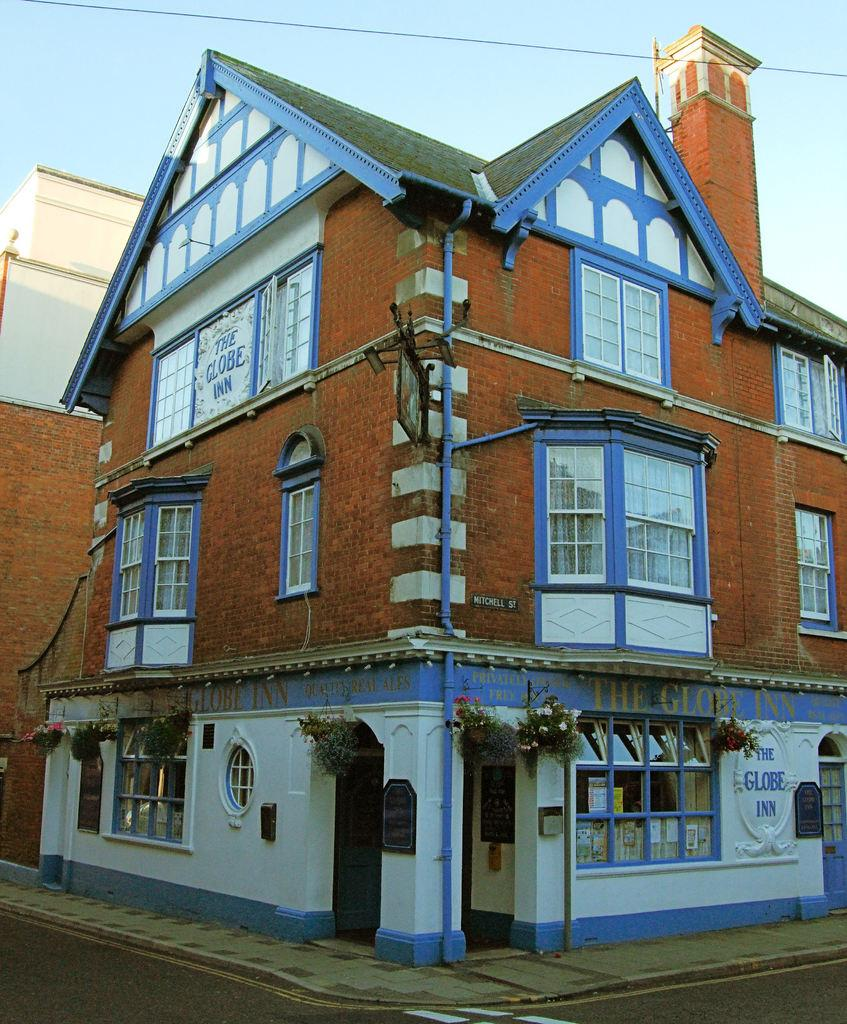What type of structure is in the image? There is a building in the image. What feature of the building is mentioned in the facts? The building has windows. What other objects or elements can be seen in the image? Pipes, a plant, a road, electric wires, and the sky are visible in the image. What type of corn is growing on the electric wires in the image? There is no corn present in the image; the electric wires are not associated with any plants or crops. 